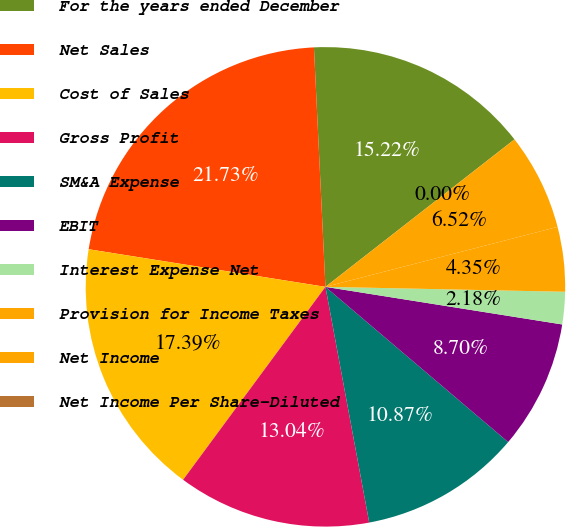<chart> <loc_0><loc_0><loc_500><loc_500><pie_chart><fcel>For the years ended December<fcel>Net Sales<fcel>Cost of Sales<fcel>Gross Profit<fcel>SM&A Expense<fcel>EBIT<fcel>Interest Expense Net<fcel>Provision for Income Taxes<fcel>Net Income<fcel>Net Income Per Share-Diluted<nl><fcel>15.22%<fcel>21.73%<fcel>17.39%<fcel>13.04%<fcel>10.87%<fcel>8.7%<fcel>2.18%<fcel>4.35%<fcel>6.52%<fcel>0.0%<nl></chart> 